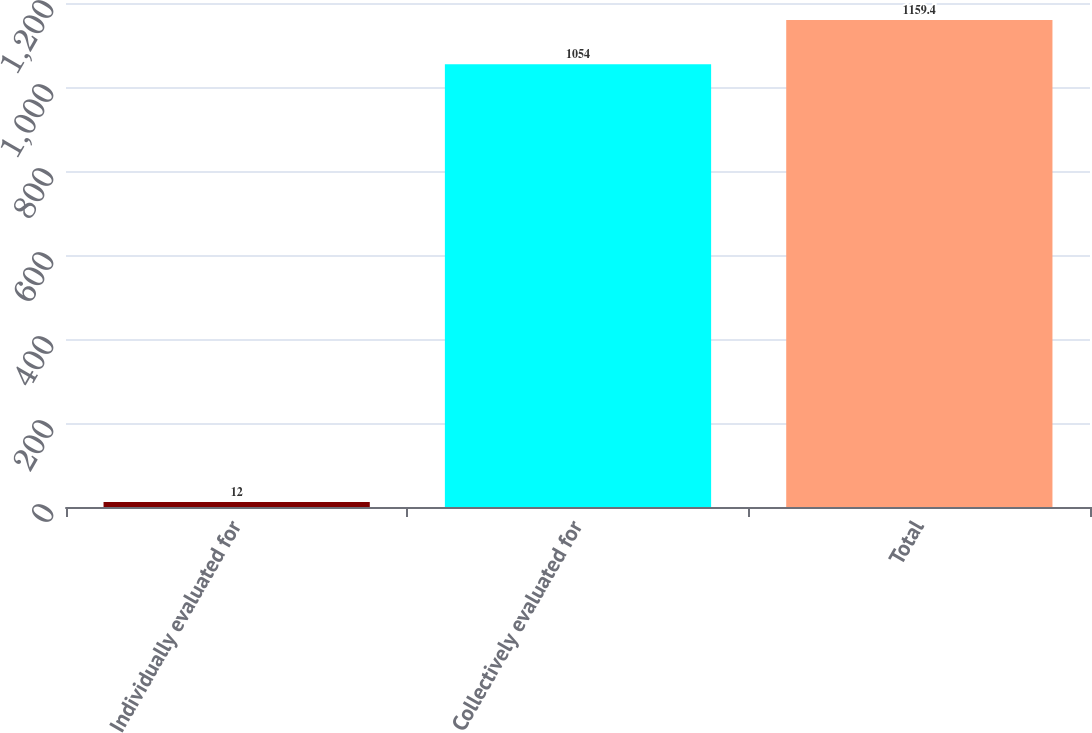Convert chart to OTSL. <chart><loc_0><loc_0><loc_500><loc_500><bar_chart><fcel>Individually evaluated for<fcel>Collectively evaluated for<fcel>Total<nl><fcel>12<fcel>1054<fcel>1159.4<nl></chart> 